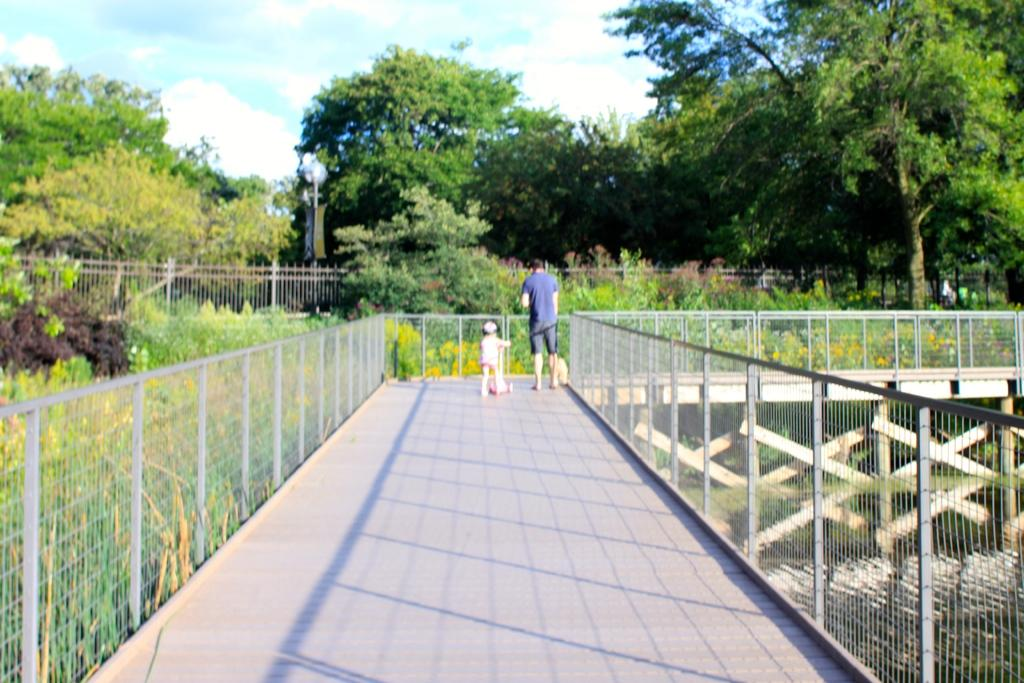What is the kid holding in the image? The kid is holding a scooter in the image. Where is the man located in the image? The man is standing on a bridge in the image. What can be seen in the background of the image? In the background of the image, there is a fence, trees, poles, plants with flowers, and clouds visible in the sky. What type of ornament is the kid wearing on their head in the image? There is no ornament visible on the kid's head in the image. What book is the man reading while standing on the bridge in the image? There is no book present in the image; the man is simply standing on the bridge. 